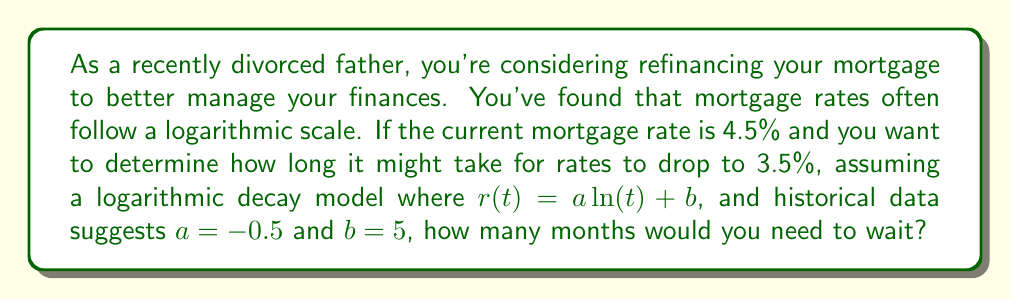Show me your answer to this math problem. Let's approach this step-by-step:

1) The logarithmic model for the mortgage rate is given by:
   $$r(t) = a \ln(t) + b$$
   where $r(t)$ is the rate at time $t$, $a = -0.5$, and $b = 5$.

2) We know the current rate is 4.5%, so let's set $t = 1$ (representing now) and verify:
   $$4.5 \approx -0.5 \ln(1) + 5 = 5$$
   This checks out as $\ln(1) = 0$.

3) We want to find when the rate will be 3.5%. Let's set up the equation:
   $$3.5 = -0.5 \ln(t) + 5$$

4) Subtract 5 from both sides:
   $$-1.5 = -0.5 \ln(t)$$

5) Divide both sides by -0.5:
   $$3 = \ln(t)$$

6) To solve for $t$, we need to apply the exponential function to both sides:
   $$e^3 = t$$

7) Calculate this value:
   $$t \approx 20.09$$

8) Since $t$ represents months in this context, we need to round up to the nearest whole month.
Answer: You would need to wait approximately 21 months for the mortgage rate to drop to 3.5%, according to this logarithmic model. 